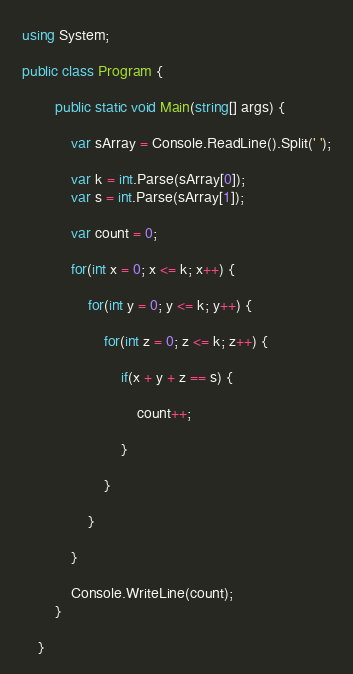<code> <loc_0><loc_0><loc_500><loc_500><_C#_>using System;

public class Program {

        public static void Main(string[] args) {

            var sArray = Console.ReadLine().Split(' ');

            var k = int.Parse(sArray[0]);
            var s = int.Parse(sArray[1]);

            var count = 0;

            for(int x = 0; x <= k; x++) {

                for(int y = 0; y <= k; y++) {

                    for(int z = 0; z <= k; z++) {

                        if(x + y + z == s) {

                            count++;

                        }

                    }

                }

            }

            Console.WriteLine(count);
        }

    }</code> 